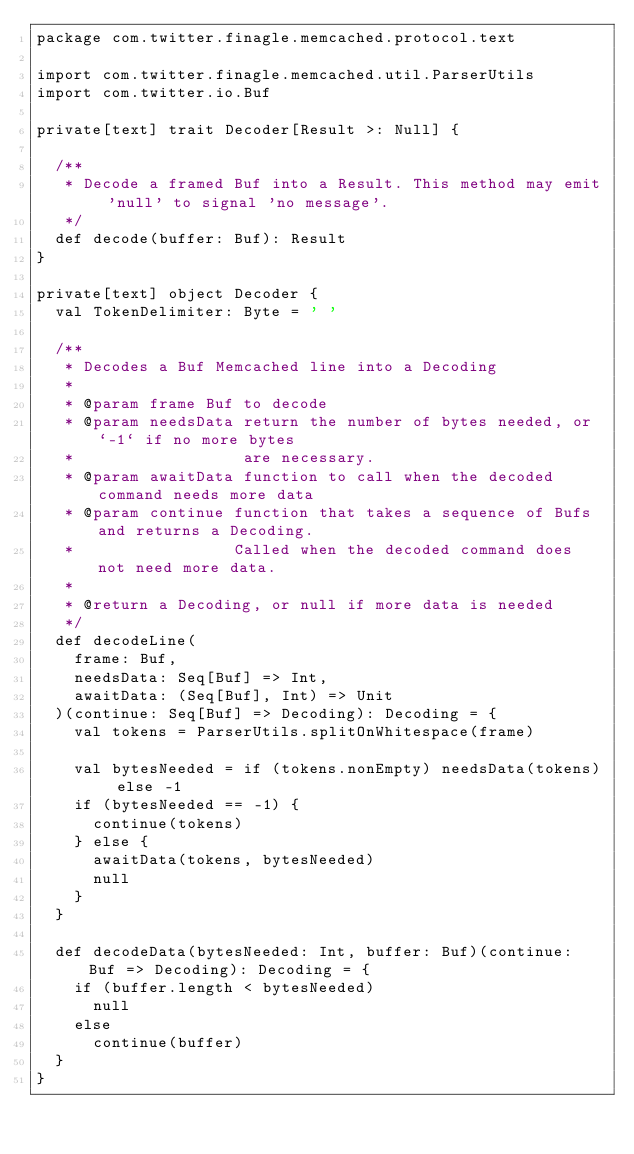Convert code to text. <code><loc_0><loc_0><loc_500><loc_500><_Scala_>package com.twitter.finagle.memcached.protocol.text

import com.twitter.finagle.memcached.util.ParserUtils
import com.twitter.io.Buf

private[text] trait Decoder[Result >: Null] {

  /**
   * Decode a framed Buf into a Result. This method may emit 'null' to signal 'no message'.
   */
  def decode(buffer: Buf): Result
}

private[text] object Decoder {
  val TokenDelimiter: Byte = ' '

  /**
   * Decodes a Buf Memcached line into a Decoding
   *
   * @param frame Buf to decode
   * @param needsData return the number of bytes needed, or `-1` if no more bytes
   *                  are necessary.
   * @param awaitData function to call when the decoded command needs more data
   * @param continue function that takes a sequence of Bufs and returns a Decoding.
   *                 Called when the decoded command does not need more data.
   *
   * @return a Decoding, or null if more data is needed
   */
  def decodeLine(
    frame: Buf,
    needsData: Seq[Buf] => Int,
    awaitData: (Seq[Buf], Int) => Unit
  )(continue: Seq[Buf] => Decoding): Decoding = {
    val tokens = ParserUtils.splitOnWhitespace(frame)

    val bytesNeeded = if (tokens.nonEmpty) needsData(tokens) else -1
    if (bytesNeeded == -1) {
      continue(tokens)
    } else {
      awaitData(tokens, bytesNeeded)
      null
    }
  }

  def decodeData(bytesNeeded: Int, buffer: Buf)(continue: Buf => Decoding): Decoding = {
    if (buffer.length < bytesNeeded)
      null
    else
      continue(buffer)
  }
}
</code> 